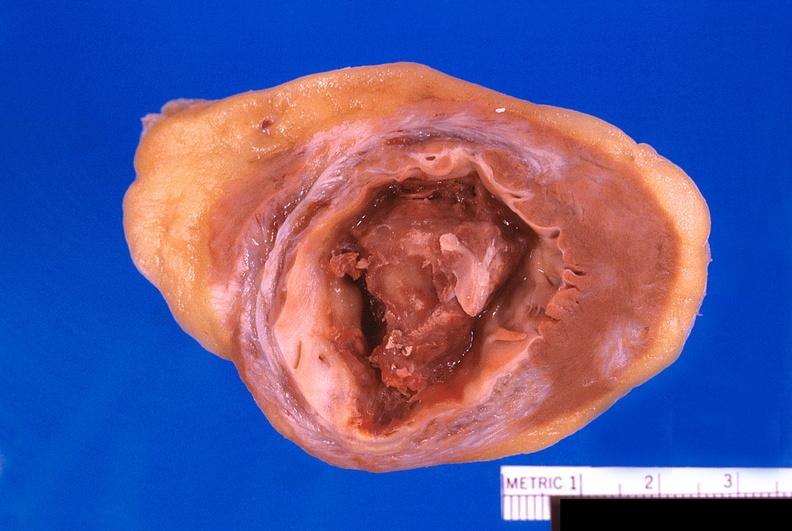how does this image show heart, old myocardial infarction?
Answer the question using a single word or phrase. With fibrosis and apical thrombus 